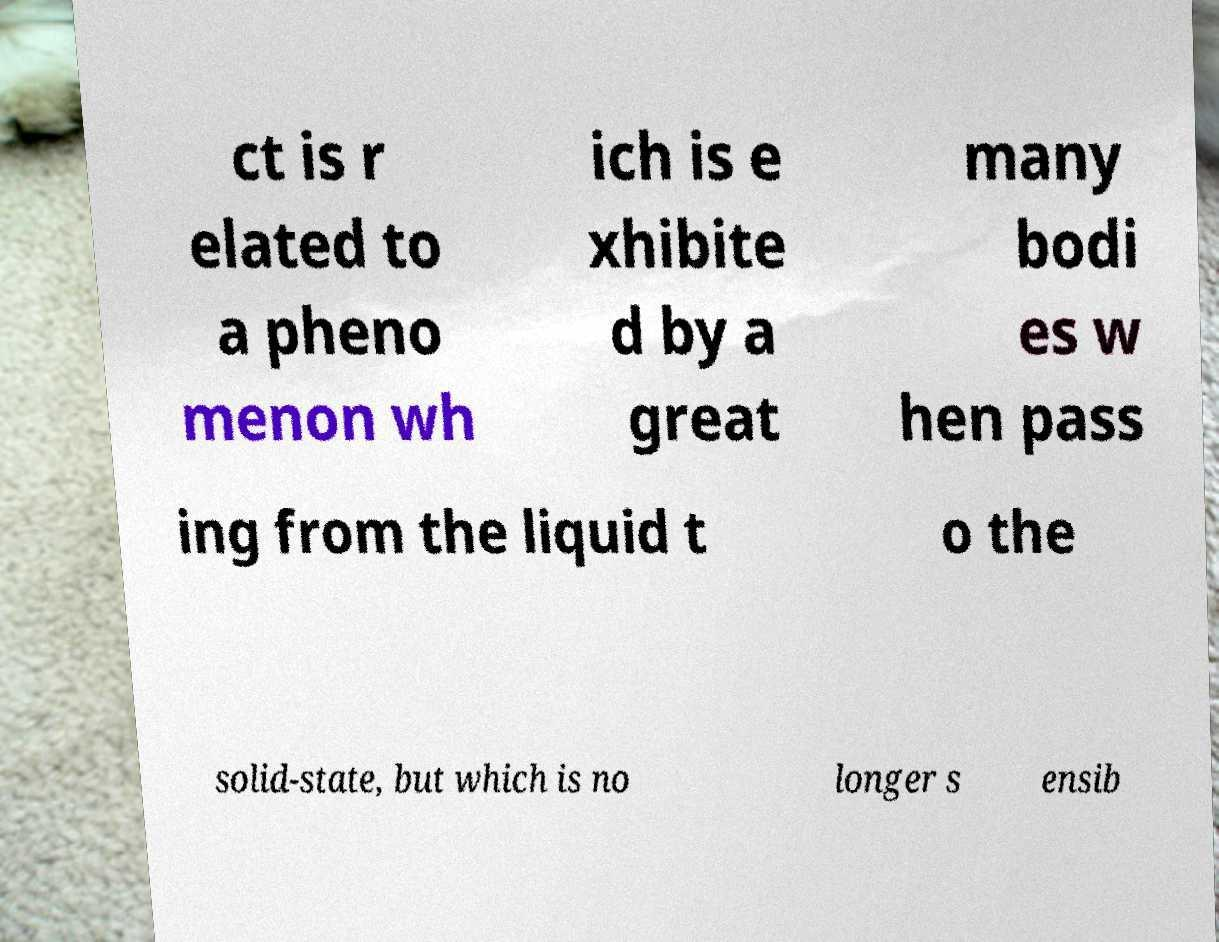Please identify and transcribe the text found in this image. ct is r elated to a pheno menon wh ich is e xhibite d by a great many bodi es w hen pass ing from the liquid t o the solid-state, but which is no longer s ensib 